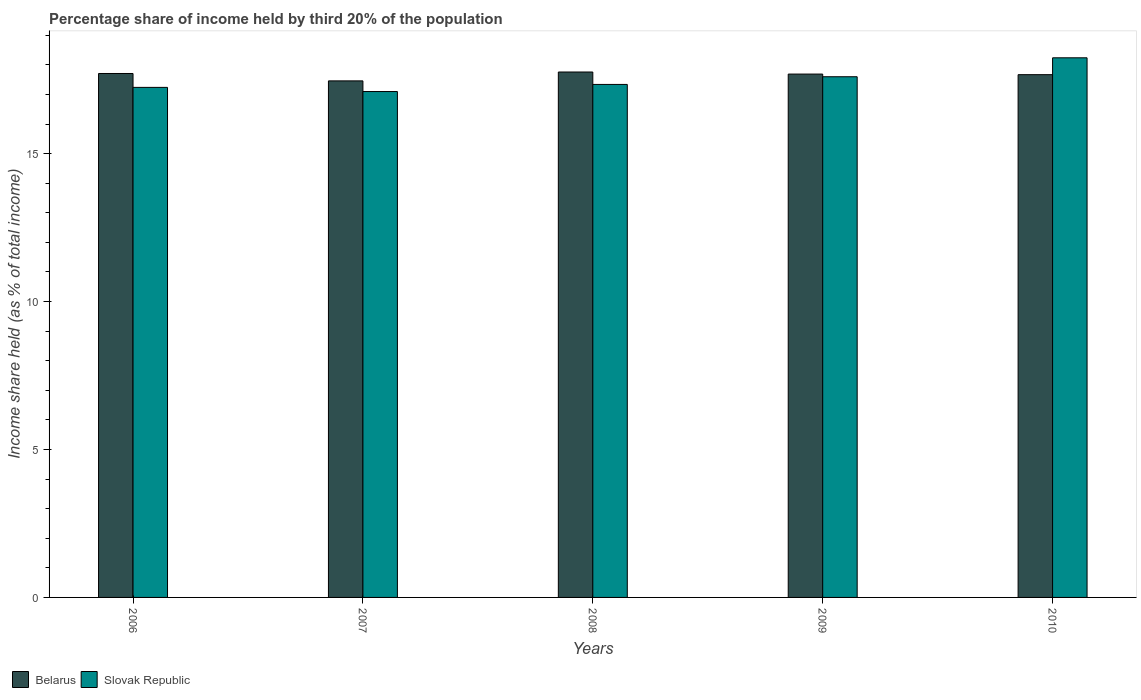How many different coloured bars are there?
Make the answer very short. 2. How many groups of bars are there?
Make the answer very short. 5. How many bars are there on the 5th tick from the left?
Provide a short and direct response. 2. How many bars are there on the 4th tick from the right?
Your response must be concise. 2. What is the label of the 5th group of bars from the left?
Your answer should be very brief. 2010. Across all years, what is the maximum share of income held by third 20% of the population in Slovak Republic?
Your answer should be compact. 18.24. Across all years, what is the minimum share of income held by third 20% of the population in Belarus?
Keep it short and to the point. 17.46. What is the total share of income held by third 20% of the population in Belarus in the graph?
Provide a short and direct response. 88.29. What is the difference between the share of income held by third 20% of the population in Belarus in 2006 and that in 2008?
Your answer should be very brief. -0.05. What is the difference between the share of income held by third 20% of the population in Slovak Republic in 2007 and the share of income held by third 20% of the population in Belarus in 2010?
Offer a very short reply. -0.57. What is the average share of income held by third 20% of the population in Slovak Republic per year?
Provide a short and direct response. 17.5. In the year 2006, what is the difference between the share of income held by third 20% of the population in Slovak Republic and share of income held by third 20% of the population in Belarus?
Provide a succinct answer. -0.47. What is the ratio of the share of income held by third 20% of the population in Slovak Republic in 2008 to that in 2009?
Your answer should be compact. 0.99. Is the difference between the share of income held by third 20% of the population in Slovak Republic in 2008 and 2009 greater than the difference between the share of income held by third 20% of the population in Belarus in 2008 and 2009?
Your answer should be compact. No. What is the difference between the highest and the second highest share of income held by third 20% of the population in Belarus?
Provide a short and direct response. 0.05. What is the difference between the highest and the lowest share of income held by third 20% of the population in Slovak Republic?
Ensure brevity in your answer.  1.14. Is the sum of the share of income held by third 20% of the population in Slovak Republic in 2008 and 2009 greater than the maximum share of income held by third 20% of the population in Belarus across all years?
Keep it short and to the point. Yes. What does the 1st bar from the left in 2008 represents?
Provide a short and direct response. Belarus. What does the 1st bar from the right in 2009 represents?
Keep it short and to the point. Slovak Republic. How many years are there in the graph?
Provide a short and direct response. 5. What is the difference between two consecutive major ticks on the Y-axis?
Ensure brevity in your answer.  5. What is the title of the graph?
Give a very brief answer. Percentage share of income held by third 20% of the population. What is the label or title of the Y-axis?
Give a very brief answer. Income share held (as % of total income). What is the Income share held (as % of total income) in Belarus in 2006?
Provide a succinct answer. 17.71. What is the Income share held (as % of total income) of Slovak Republic in 2006?
Offer a terse response. 17.24. What is the Income share held (as % of total income) of Belarus in 2007?
Make the answer very short. 17.46. What is the Income share held (as % of total income) in Slovak Republic in 2007?
Provide a short and direct response. 17.1. What is the Income share held (as % of total income) of Belarus in 2008?
Offer a very short reply. 17.76. What is the Income share held (as % of total income) in Slovak Republic in 2008?
Your answer should be very brief. 17.34. What is the Income share held (as % of total income) in Belarus in 2009?
Your answer should be compact. 17.69. What is the Income share held (as % of total income) in Slovak Republic in 2009?
Give a very brief answer. 17.6. What is the Income share held (as % of total income) in Belarus in 2010?
Make the answer very short. 17.67. What is the Income share held (as % of total income) of Slovak Republic in 2010?
Your response must be concise. 18.24. Across all years, what is the maximum Income share held (as % of total income) of Belarus?
Your answer should be very brief. 17.76. Across all years, what is the maximum Income share held (as % of total income) in Slovak Republic?
Your answer should be compact. 18.24. Across all years, what is the minimum Income share held (as % of total income) of Belarus?
Provide a short and direct response. 17.46. Across all years, what is the minimum Income share held (as % of total income) in Slovak Republic?
Offer a terse response. 17.1. What is the total Income share held (as % of total income) of Belarus in the graph?
Your answer should be very brief. 88.29. What is the total Income share held (as % of total income) of Slovak Republic in the graph?
Make the answer very short. 87.52. What is the difference between the Income share held (as % of total income) of Belarus in 2006 and that in 2007?
Offer a very short reply. 0.25. What is the difference between the Income share held (as % of total income) of Slovak Republic in 2006 and that in 2007?
Your answer should be very brief. 0.14. What is the difference between the Income share held (as % of total income) of Slovak Republic in 2006 and that in 2009?
Your response must be concise. -0.36. What is the difference between the Income share held (as % of total income) in Slovak Republic in 2007 and that in 2008?
Offer a very short reply. -0.24. What is the difference between the Income share held (as % of total income) in Belarus in 2007 and that in 2009?
Make the answer very short. -0.23. What is the difference between the Income share held (as % of total income) in Belarus in 2007 and that in 2010?
Offer a very short reply. -0.21. What is the difference between the Income share held (as % of total income) of Slovak Republic in 2007 and that in 2010?
Give a very brief answer. -1.14. What is the difference between the Income share held (as % of total income) of Belarus in 2008 and that in 2009?
Give a very brief answer. 0.07. What is the difference between the Income share held (as % of total income) in Slovak Republic in 2008 and that in 2009?
Offer a terse response. -0.26. What is the difference between the Income share held (as % of total income) of Belarus in 2008 and that in 2010?
Give a very brief answer. 0.09. What is the difference between the Income share held (as % of total income) of Slovak Republic in 2009 and that in 2010?
Give a very brief answer. -0.64. What is the difference between the Income share held (as % of total income) in Belarus in 2006 and the Income share held (as % of total income) in Slovak Republic in 2007?
Your answer should be very brief. 0.61. What is the difference between the Income share held (as % of total income) in Belarus in 2006 and the Income share held (as % of total income) in Slovak Republic in 2008?
Your answer should be compact. 0.37. What is the difference between the Income share held (as % of total income) in Belarus in 2006 and the Income share held (as % of total income) in Slovak Republic in 2009?
Ensure brevity in your answer.  0.11. What is the difference between the Income share held (as % of total income) of Belarus in 2006 and the Income share held (as % of total income) of Slovak Republic in 2010?
Your answer should be compact. -0.53. What is the difference between the Income share held (as % of total income) in Belarus in 2007 and the Income share held (as % of total income) in Slovak Republic in 2008?
Offer a terse response. 0.12. What is the difference between the Income share held (as % of total income) in Belarus in 2007 and the Income share held (as % of total income) in Slovak Republic in 2009?
Offer a terse response. -0.14. What is the difference between the Income share held (as % of total income) in Belarus in 2007 and the Income share held (as % of total income) in Slovak Republic in 2010?
Make the answer very short. -0.78. What is the difference between the Income share held (as % of total income) in Belarus in 2008 and the Income share held (as % of total income) in Slovak Republic in 2009?
Make the answer very short. 0.16. What is the difference between the Income share held (as % of total income) of Belarus in 2008 and the Income share held (as % of total income) of Slovak Republic in 2010?
Ensure brevity in your answer.  -0.48. What is the difference between the Income share held (as % of total income) of Belarus in 2009 and the Income share held (as % of total income) of Slovak Republic in 2010?
Give a very brief answer. -0.55. What is the average Income share held (as % of total income) in Belarus per year?
Provide a short and direct response. 17.66. What is the average Income share held (as % of total income) in Slovak Republic per year?
Keep it short and to the point. 17.5. In the year 2006, what is the difference between the Income share held (as % of total income) of Belarus and Income share held (as % of total income) of Slovak Republic?
Offer a terse response. 0.47. In the year 2007, what is the difference between the Income share held (as % of total income) of Belarus and Income share held (as % of total income) of Slovak Republic?
Provide a short and direct response. 0.36. In the year 2008, what is the difference between the Income share held (as % of total income) in Belarus and Income share held (as % of total income) in Slovak Republic?
Offer a very short reply. 0.42. In the year 2009, what is the difference between the Income share held (as % of total income) of Belarus and Income share held (as % of total income) of Slovak Republic?
Your answer should be very brief. 0.09. In the year 2010, what is the difference between the Income share held (as % of total income) of Belarus and Income share held (as % of total income) of Slovak Republic?
Your response must be concise. -0.57. What is the ratio of the Income share held (as % of total income) of Belarus in 2006 to that in 2007?
Offer a terse response. 1.01. What is the ratio of the Income share held (as % of total income) in Slovak Republic in 2006 to that in 2007?
Keep it short and to the point. 1.01. What is the ratio of the Income share held (as % of total income) of Slovak Republic in 2006 to that in 2008?
Your answer should be compact. 0.99. What is the ratio of the Income share held (as % of total income) in Slovak Republic in 2006 to that in 2009?
Your answer should be very brief. 0.98. What is the ratio of the Income share held (as % of total income) of Slovak Republic in 2006 to that in 2010?
Ensure brevity in your answer.  0.95. What is the ratio of the Income share held (as % of total income) in Belarus in 2007 to that in 2008?
Your answer should be compact. 0.98. What is the ratio of the Income share held (as % of total income) of Slovak Republic in 2007 to that in 2008?
Ensure brevity in your answer.  0.99. What is the ratio of the Income share held (as % of total income) of Belarus in 2007 to that in 2009?
Your answer should be compact. 0.99. What is the ratio of the Income share held (as % of total income) of Slovak Republic in 2007 to that in 2009?
Offer a terse response. 0.97. What is the ratio of the Income share held (as % of total income) in Slovak Republic in 2007 to that in 2010?
Offer a very short reply. 0.94. What is the ratio of the Income share held (as % of total income) of Belarus in 2008 to that in 2009?
Keep it short and to the point. 1. What is the ratio of the Income share held (as % of total income) of Slovak Republic in 2008 to that in 2009?
Offer a very short reply. 0.99. What is the ratio of the Income share held (as % of total income) in Slovak Republic in 2008 to that in 2010?
Your answer should be compact. 0.95. What is the ratio of the Income share held (as % of total income) of Belarus in 2009 to that in 2010?
Give a very brief answer. 1. What is the ratio of the Income share held (as % of total income) of Slovak Republic in 2009 to that in 2010?
Offer a very short reply. 0.96. What is the difference between the highest and the second highest Income share held (as % of total income) in Belarus?
Your answer should be very brief. 0.05. What is the difference between the highest and the second highest Income share held (as % of total income) of Slovak Republic?
Your response must be concise. 0.64. What is the difference between the highest and the lowest Income share held (as % of total income) in Slovak Republic?
Your answer should be compact. 1.14. 